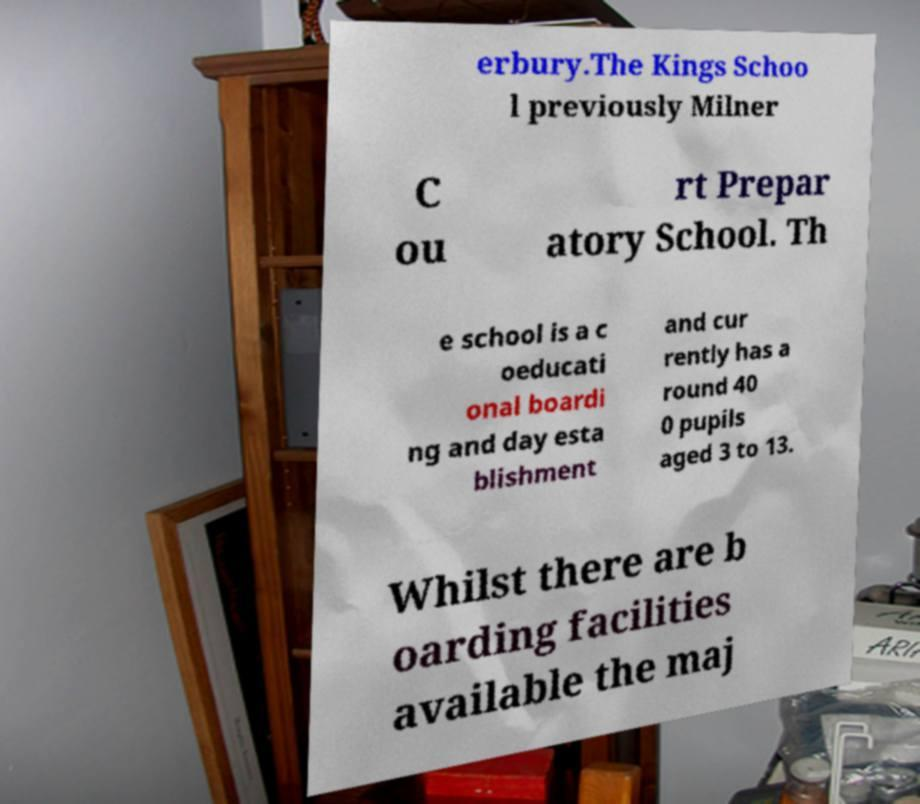Could you extract and type out the text from this image? erbury.The Kings Schoo l previously Milner C ou rt Prepar atory School. Th e school is a c oeducati onal boardi ng and day esta blishment and cur rently has a round 40 0 pupils aged 3 to 13. Whilst there are b oarding facilities available the maj 